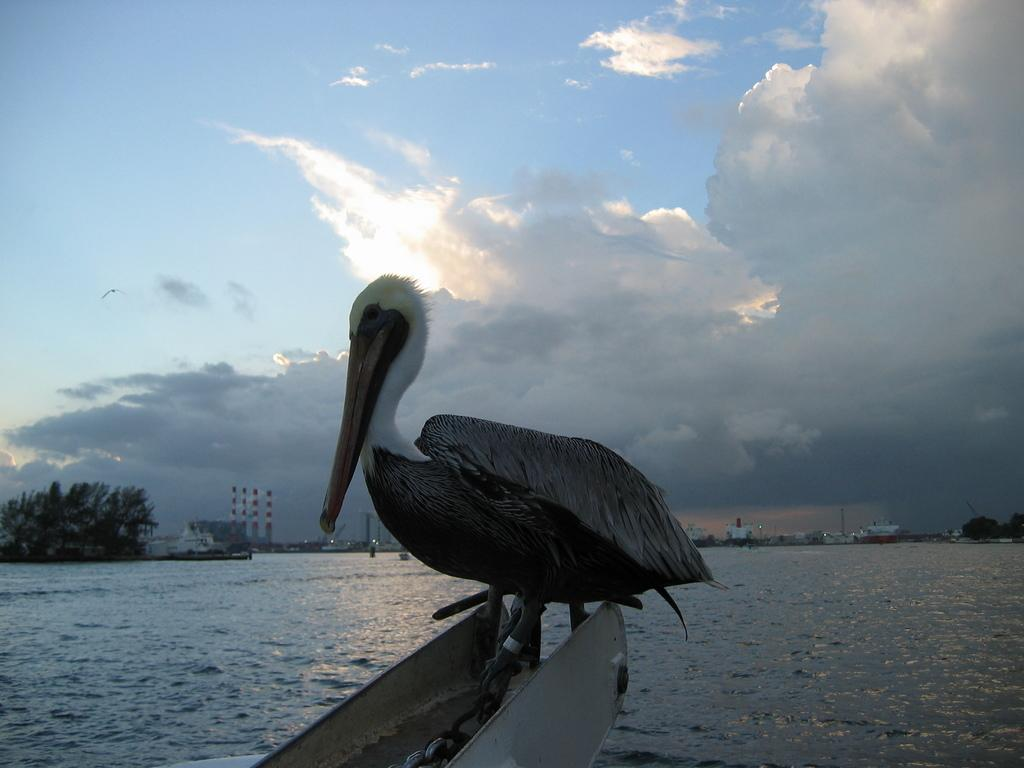What is the main subject in the foreground of the image? There is a bird in the foreground of the image. What can be seen in the background of the image? There is a water body, trees, and buildings in the background of the image. What is the condition of the sky in the image? The sky is cloudy in the image. What is your uncle's opinion about the silver bird in the image? There is no reference to an uncle or a silver bird in the image, so it is not possible to answer that question. 